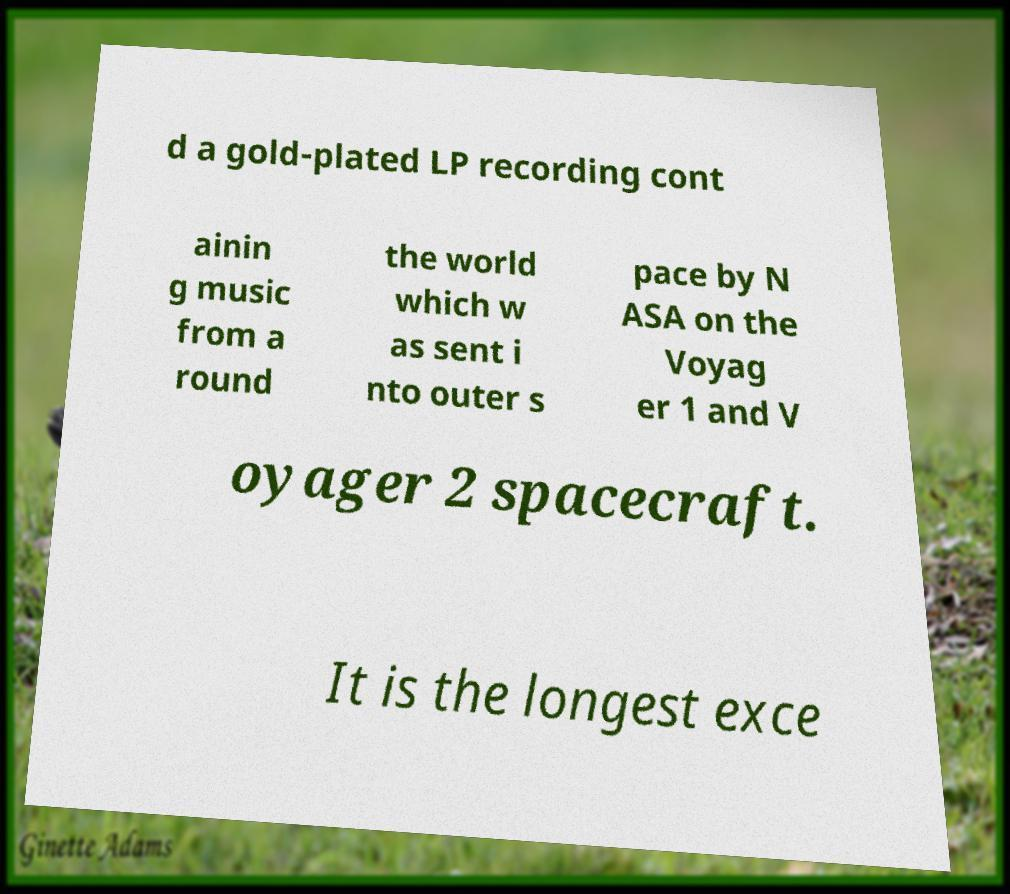What messages or text are displayed in this image? I need them in a readable, typed format. d a gold-plated LP recording cont ainin g music from a round the world which w as sent i nto outer s pace by N ASA on the Voyag er 1 and V oyager 2 spacecraft. It is the longest exce 